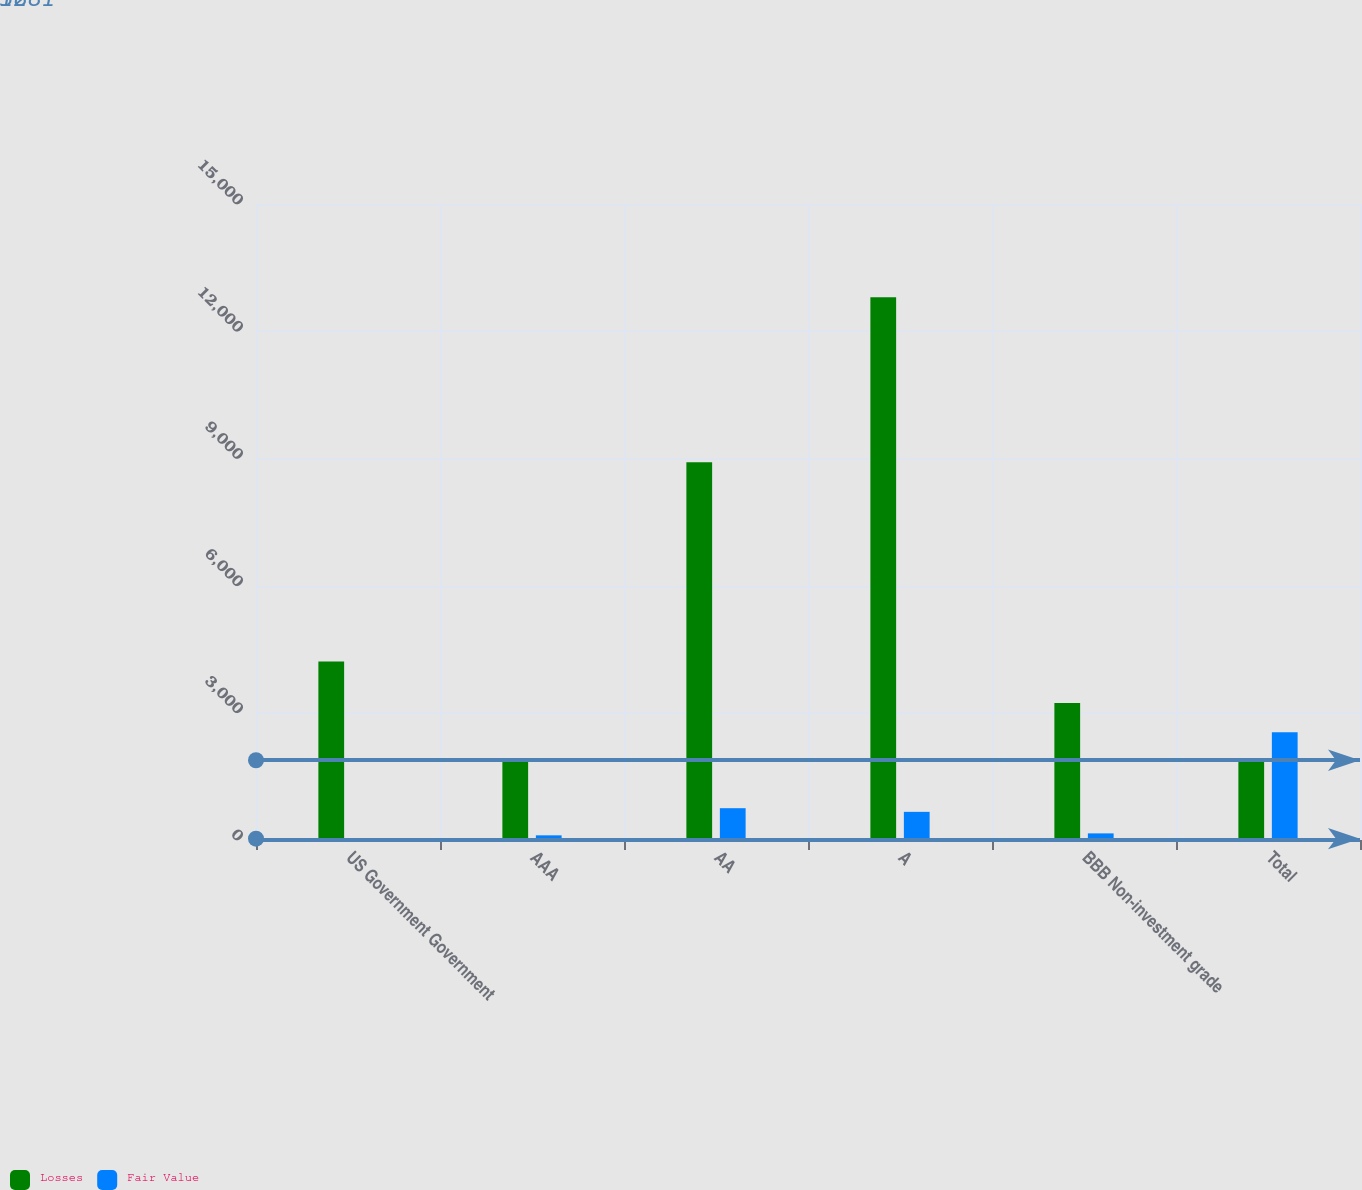<chart> <loc_0><loc_0><loc_500><loc_500><stacked_bar_chart><ecel><fcel>US Government Government<fcel>AAA<fcel>AA<fcel>A<fcel>BBB Non-investment grade<fcel>Total<nl><fcel>Losses<fcel>4212<fcel>1881<fcel>8911<fcel>12802<fcel>3233<fcel>1881<nl><fcel>Fair Value<fcel>32<fcel>110<fcel>750<fcel>664<fcel>156<fcel>2544<nl></chart> 